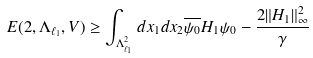<formula> <loc_0><loc_0><loc_500><loc_500>E ( 2 , \Lambda _ { \ell _ { 1 } } , V ) \geq \int _ { \Lambda _ { \ell _ { 1 } } ^ { 2 } } d x _ { 1 } d x _ { 2 } \overline { \psi _ { 0 } } H _ { 1 } \psi _ { 0 } - \frac { 2 \| H _ { 1 } \| _ { \infty } ^ { 2 } } { \gamma }</formula> 